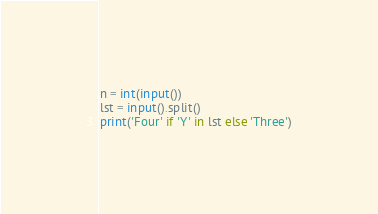Convert code to text. <code><loc_0><loc_0><loc_500><loc_500><_Python_>n = int(input())
lst = input().split()
print('Four' if 'Y' in lst else 'Three')</code> 